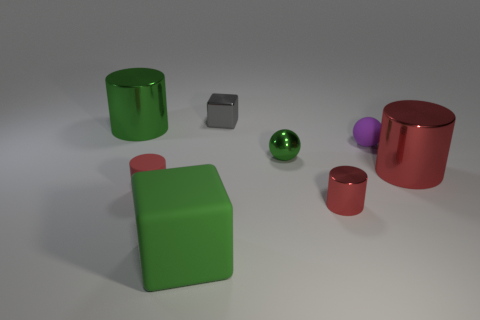Does the rubber cube have the same color as the tiny metal ball?
Keep it short and to the point. Yes. Do the shiny cylinder left of the tiny gray thing and the tiny ball that is to the left of the purple matte ball have the same color?
Offer a terse response. Yes. What is the size of the green matte object?
Provide a succinct answer. Large. The small object that is right of the large cube and in front of the small green thing is what color?
Your answer should be very brief. Red. Is the number of tiny gray metal cubes greater than the number of red metal objects?
Your answer should be compact. No. How many things are small red cylinders or green metallic objects right of the big matte cube?
Ensure brevity in your answer.  3. Do the rubber cube and the purple matte sphere have the same size?
Ensure brevity in your answer.  No. Are there any big metal objects on the right side of the tiny gray metallic object?
Your answer should be compact. Yes. There is a shiny cylinder that is behind the red matte cylinder and to the right of the large rubber block; what is its size?
Your answer should be very brief. Large. What number of things are small purple objects or cylinders?
Your answer should be very brief. 5. 